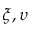Convert formula to latex. <formula><loc_0><loc_0><loc_500><loc_500>\xi , \upsilon</formula> 